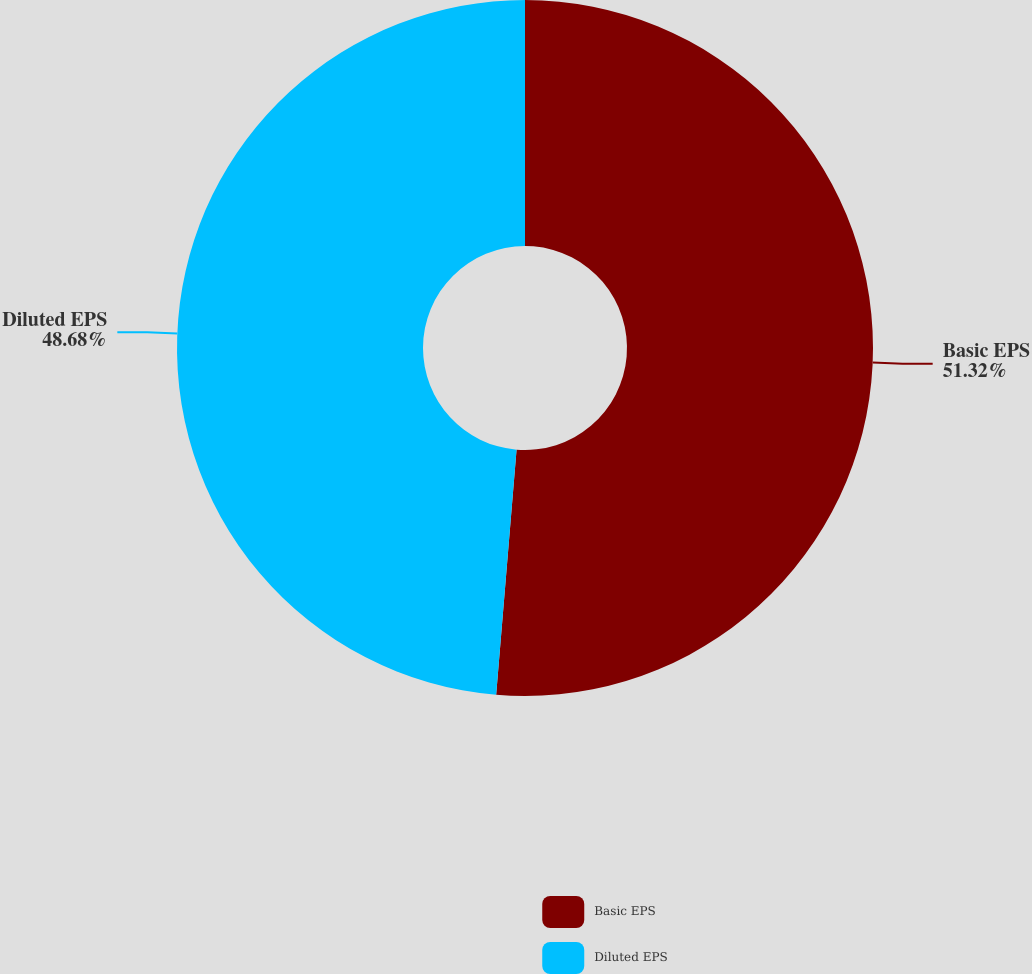<chart> <loc_0><loc_0><loc_500><loc_500><pie_chart><fcel>Basic EPS<fcel>Diluted EPS<nl><fcel>51.32%<fcel>48.68%<nl></chart> 